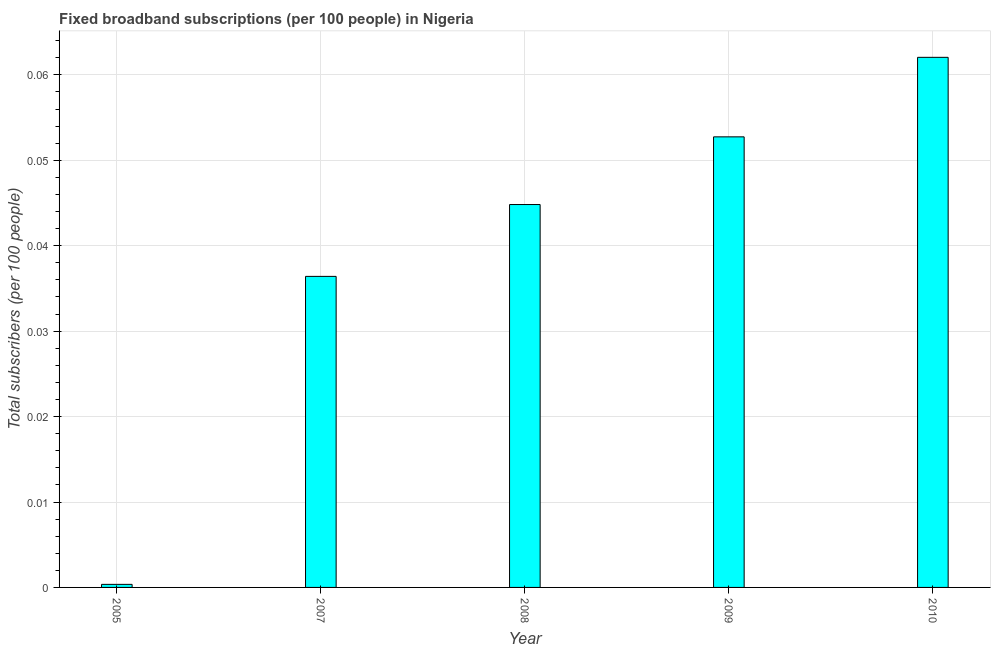Does the graph contain any zero values?
Your answer should be very brief. No. What is the title of the graph?
Ensure brevity in your answer.  Fixed broadband subscriptions (per 100 people) in Nigeria. What is the label or title of the X-axis?
Offer a terse response. Year. What is the label or title of the Y-axis?
Make the answer very short. Total subscribers (per 100 people). What is the total number of fixed broadband subscriptions in 2010?
Offer a very short reply. 0.06. Across all years, what is the maximum total number of fixed broadband subscriptions?
Ensure brevity in your answer.  0.06. Across all years, what is the minimum total number of fixed broadband subscriptions?
Make the answer very short. 0. In which year was the total number of fixed broadband subscriptions minimum?
Your answer should be compact. 2005. What is the sum of the total number of fixed broadband subscriptions?
Your response must be concise. 0.2. What is the difference between the total number of fixed broadband subscriptions in 2007 and 2009?
Provide a short and direct response. -0.02. What is the average total number of fixed broadband subscriptions per year?
Provide a succinct answer. 0.04. What is the median total number of fixed broadband subscriptions?
Make the answer very short. 0.04. Do a majority of the years between 2008 and 2010 (inclusive) have total number of fixed broadband subscriptions greater than 0.018 ?
Offer a very short reply. Yes. What is the ratio of the total number of fixed broadband subscriptions in 2007 to that in 2009?
Your response must be concise. 0.69. What is the difference between the highest and the second highest total number of fixed broadband subscriptions?
Keep it short and to the point. 0.01. Is the sum of the total number of fixed broadband subscriptions in 2008 and 2009 greater than the maximum total number of fixed broadband subscriptions across all years?
Offer a terse response. Yes. Are all the bars in the graph horizontal?
Give a very brief answer. No. How many years are there in the graph?
Offer a terse response. 5. What is the Total subscribers (per 100 people) in 2005?
Make the answer very short. 0. What is the Total subscribers (per 100 people) in 2007?
Offer a terse response. 0.04. What is the Total subscribers (per 100 people) in 2008?
Your answer should be very brief. 0.04. What is the Total subscribers (per 100 people) in 2009?
Give a very brief answer. 0.05. What is the Total subscribers (per 100 people) in 2010?
Give a very brief answer. 0.06. What is the difference between the Total subscribers (per 100 people) in 2005 and 2007?
Offer a very short reply. -0.04. What is the difference between the Total subscribers (per 100 people) in 2005 and 2008?
Your answer should be compact. -0.04. What is the difference between the Total subscribers (per 100 people) in 2005 and 2009?
Your answer should be compact. -0.05. What is the difference between the Total subscribers (per 100 people) in 2005 and 2010?
Your answer should be very brief. -0.06. What is the difference between the Total subscribers (per 100 people) in 2007 and 2008?
Keep it short and to the point. -0.01. What is the difference between the Total subscribers (per 100 people) in 2007 and 2009?
Offer a very short reply. -0.02. What is the difference between the Total subscribers (per 100 people) in 2007 and 2010?
Your response must be concise. -0.03. What is the difference between the Total subscribers (per 100 people) in 2008 and 2009?
Your answer should be compact. -0.01. What is the difference between the Total subscribers (per 100 people) in 2008 and 2010?
Ensure brevity in your answer.  -0.02. What is the difference between the Total subscribers (per 100 people) in 2009 and 2010?
Provide a short and direct response. -0.01. What is the ratio of the Total subscribers (per 100 people) in 2005 to that in 2008?
Provide a succinct answer. 0.01. What is the ratio of the Total subscribers (per 100 people) in 2005 to that in 2009?
Your answer should be compact. 0.01. What is the ratio of the Total subscribers (per 100 people) in 2005 to that in 2010?
Offer a terse response. 0.01. What is the ratio of the Total subscribers (per 100 people) in 2007 to that in 2008?
Make the answer very short. 0.81. What is the ratio of the Total subscribers (per 100 people) in 2007 to that in 2009?
Keep it short and to the point. 0.69. What is the ratio of the Total subscribers (per 100 people) in 2007 to that in 2010?
Offer a terse response. 0.59. What is the ratio of the Total subscribers (per 100 people) in 2008 to that in 2010?
Give a very brief answer. 0.72. 